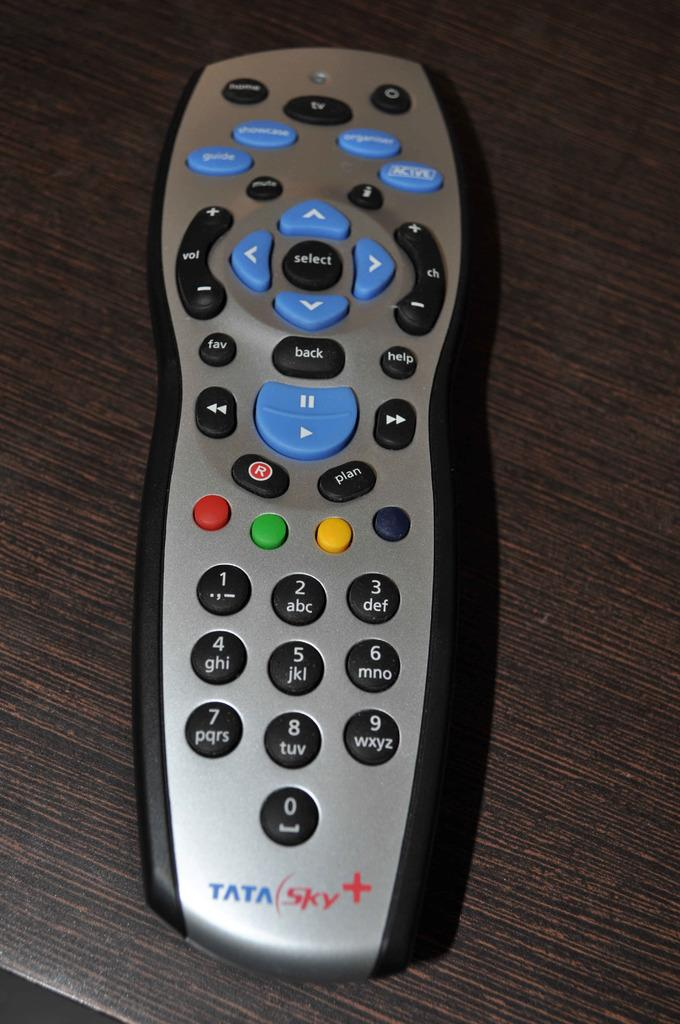<image>
Relay a brief, clear account of the picture shown. a black and silver remote that says 'tata sky' at the bottom of it 